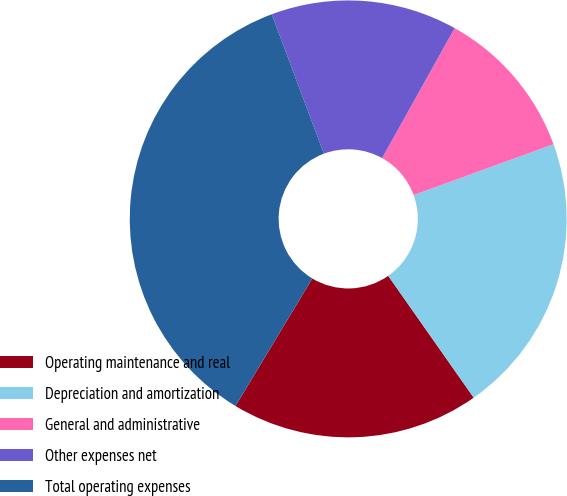<chart> <loc_0><loc_0><loc_500><loc_500><pie_chart><fcel>Operating maintenance and real<fcel>Depreciation and amortization<fcel>General and administrative<fcel>Other expenses net<fcel>Total operating expenses<nl><fcel>18.37%<fcel>20.81%<fcel>11.35%<fcel>13.79%<fcel>35.68%<nl></chart> 